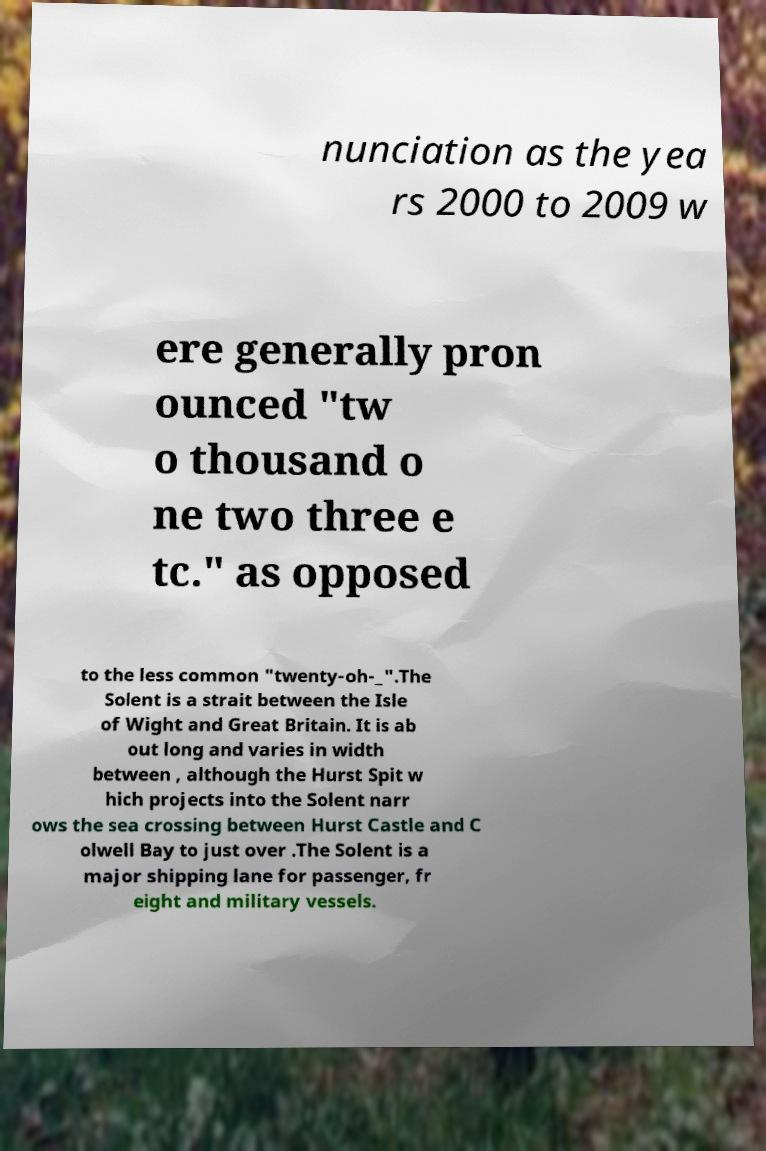Can you read and provide the text displayed in the image?This photo seems to have some interesting text. Can you extract and type it out for me? nunciation as the yea rs 2000 to 2009 w ere generally pron ounced "tw o thousand o ne two three e tc." as opposed to the less common "twenty-oh-_".The Solent is a strait between the Isle of Wight and Great Britain. It is ab out long and varies in width between , although the Hurst Spit w hich projects into the Solent narr ows the sea crossing between Hurst Castle and C olwell Bay to just over .The Solent is a major shipping lane for passenger, fr eight and military vessels. 